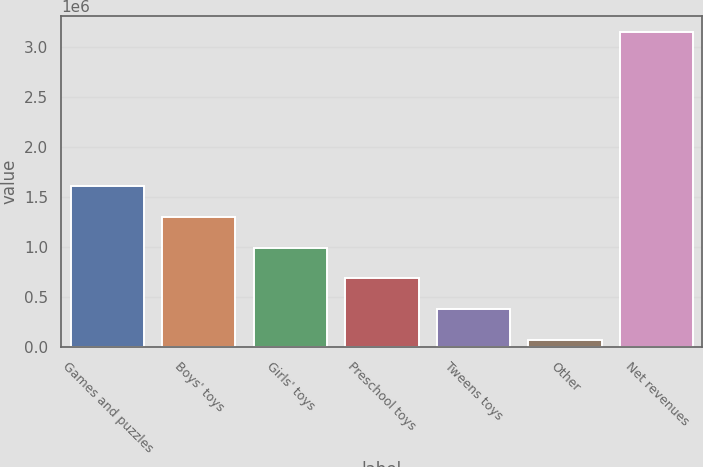Convert chart to OTSL. <chart><loc_0><loc_0><loc_500><loc_500><bar_chart><fcel>Games and puzzles<fcel>Boys' toys<fcel>Girls' toys<fcel>Preschool toys<fcel>Tweens toys<fcel>Other<fcel>Net revenues<nl><fcel>1.6096e+06<fcel>1.30123e+06<fcel>992852<fcel>684476<fcel>376101<fcel>67725<fcel>3.15148e+06<nl></chart> 